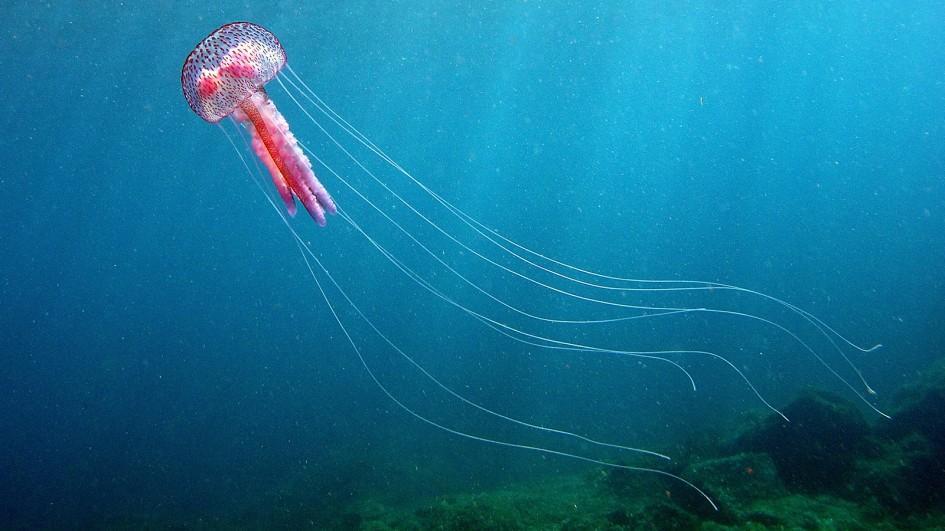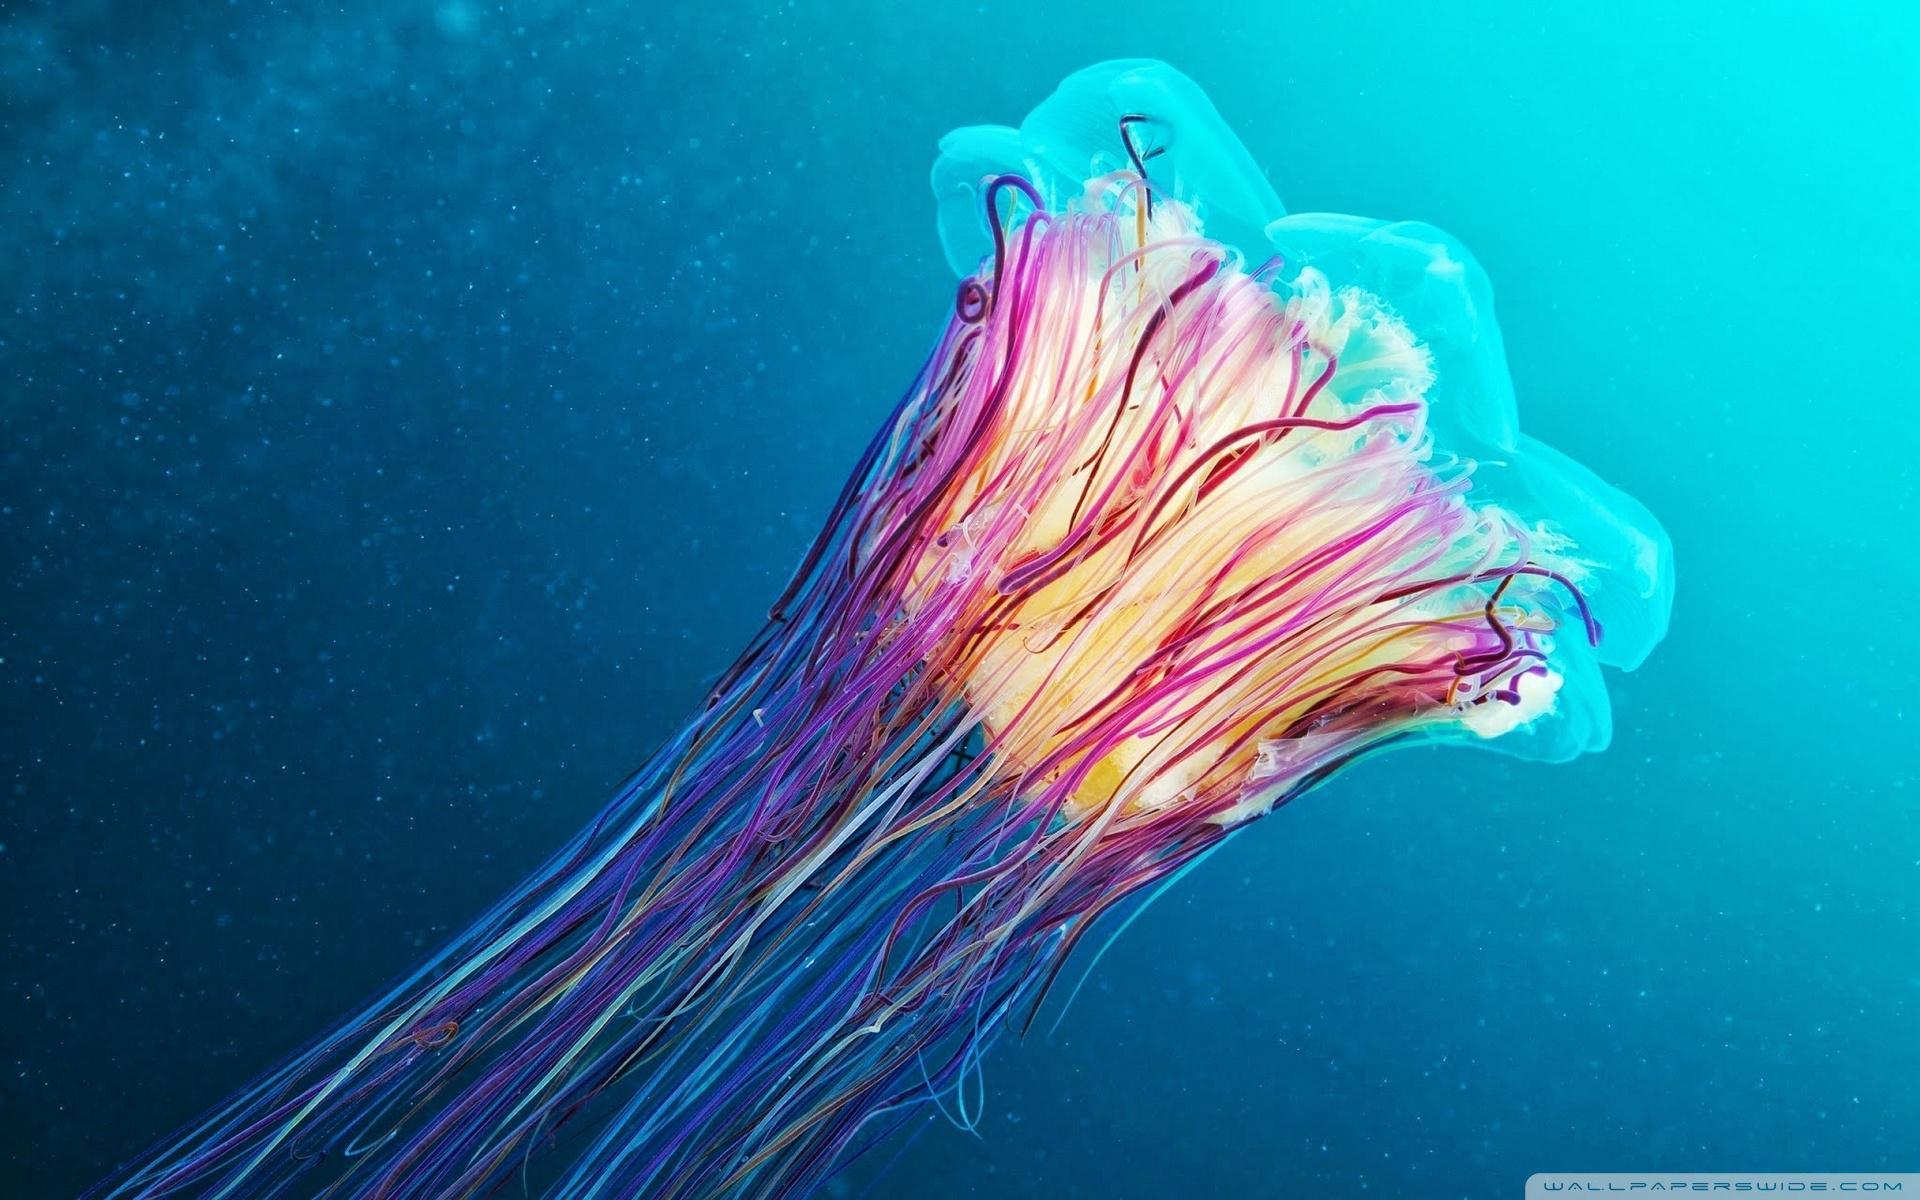The first image is the image on the left, the second image is the image on the right. Evaluate the accuracy of this statement regarding the images: "The right image shows at least one vivid orange jellyfish.". Is it true? Answer yes or no. No. 